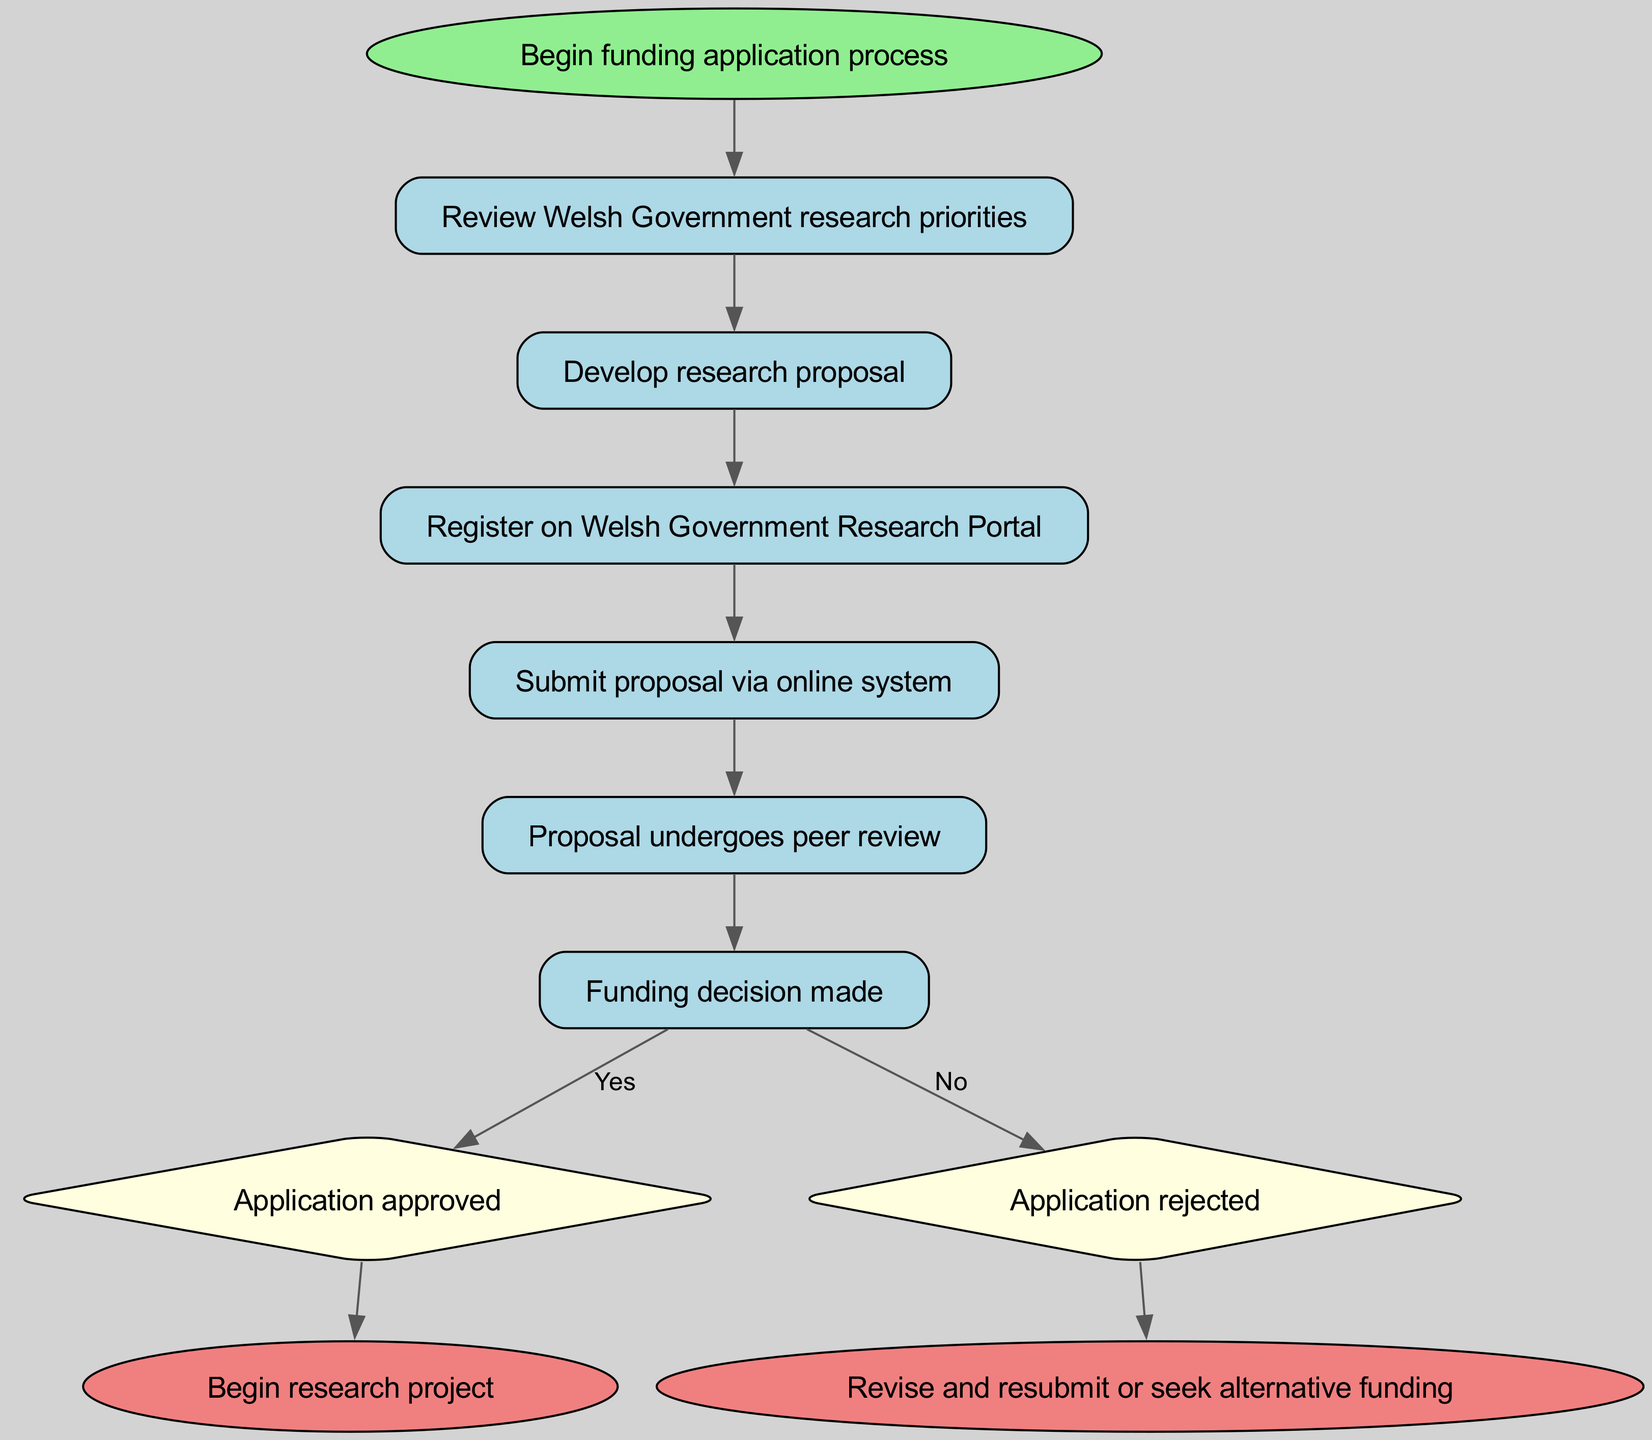What is the first step in the funding application process? The first step in the process, according to the diagram, is "Review Welsh Government research priorities." This is indicated as the first connection following the start node.
Answer: Review Welsh Government research priorities How many steps are there in the funding application process? By counting the nodes from "Begin funding application process" to "Funding decision made," including the start and end nodes, there are a total of 10 steps (including the decision and end nodes).
Answer: 10 What happens after submitting a proposal? After "Submit proposal via online system," the next step is "Proposal undergoes peer review." This shows the flow from the submission of the proposal to the review stage.
Answer: Proposal undergoes peer review What is the outcome if the funding application is approved? If the application is approved, the next step is to "Begin research project." This indicates the final outcome of the approved application.
Answer: Begin research project How does one receive a funding decision? After the proposal undergoes peer review, it leads to the "Funding decision made." This connection indicates the pathway to receiving a funding decision after reviewing the proposal.
Answer: Funding decision made What follows if the application is rejected? If the application is rejected, the flow leads to "Revise and resubmit or seek alternative funding." This connects directly from the rejected node, indicating the actions to take post-rejection.
Answer: Revise and resubmit or seek alternative funding What shape represents the funding decision in this diagram? The funding decision is represented by a diamond shape, as shown in the diagram. This indicates that it is a decision point within the process.
Answer: Diamond What role does the Welsh Government Research Portal play in the process? The Welsh Government Research Portal is where applicants must "Register" after developing their research proposal, serving as a necessary step before submission.
Answer: Register on Welsh Government Research Portal How does the flowchart indicate the process begins? The process begins at the "Begin funding application process" node, marked as the start of the flowchart and indicated with an oval shape.
Answer: Begin funding application process 